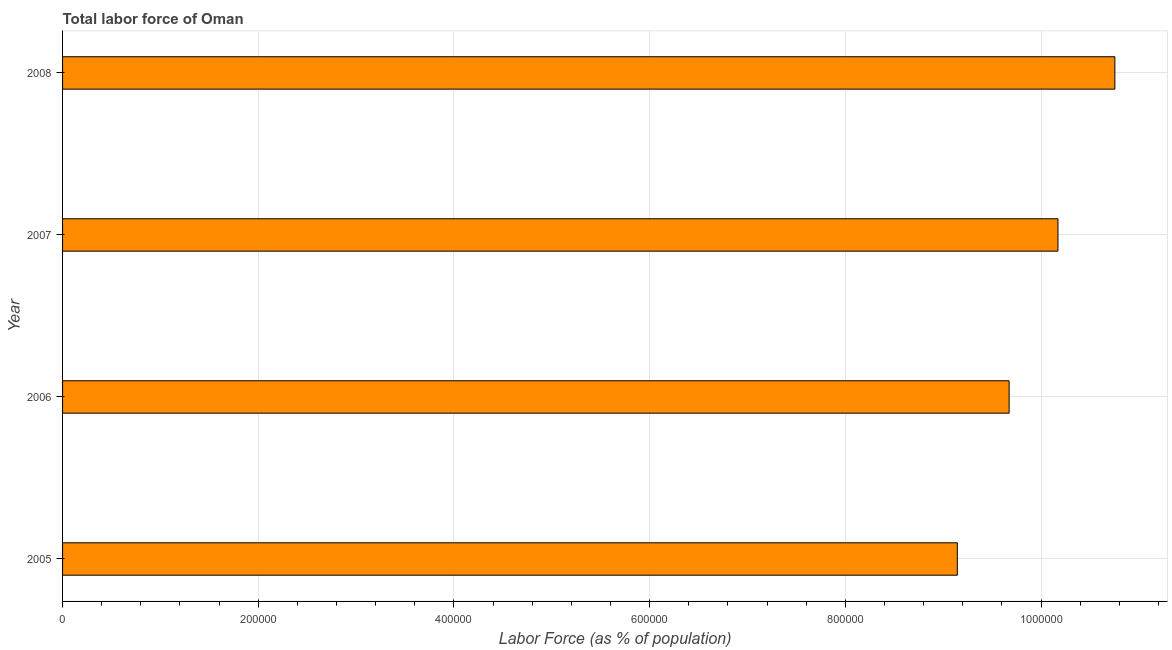Does the graph contain grids?
Keep it short and to the point. Yes. What is the title of the graph?
Your response must be concise. Total labor force of Oman. What is the label or title of the X-axis?
Keep it short and to the point. Labor Force (as % of population). What is the label or title of the Y-axis?
Give a very brief answer. Year. What is the total labor force in 2005?
Your answer should be very brief. 9.14e+05. Across all years, what is the maximum total labor force?
Provide a short and direct response. 1.08e+06. Across all years, what is the minimum total labor force?
Make the answer very short. 9.14e+05. In which year was the total labor force minimum?
Your answer should be very brief. 2005. What is the sum of the total labor force?
Keep it short and to the point. 3.97e+06. What is the difference between the total labor force in 2005 and 2006?
Offer a very short reply. -5.30e+04. What is the average total labor force per year?
Give a very brief answer. 9.94e+05. What is the median total labor force?
Offer a very short reply. 9.92e+05. What is the ratio of the total labor force in 2005 to that in 2007?
Offer a very short reply. 0.9. Is the total labor force in 2005 less than that in 2008?
Keep it short and to the point. Yes. What is the difference between the highest and the second highest total labor force?
Your answer should be compact. 5.82e+04. Is the sum of the total labor force in 2006 and 2008 greater than the maximum total labor force across all years?
Keep it short and to the point. Yes. What is the difference between the highest and the lowest total labor force?
Ensure brevity in your answer.  1.61e+05. Are all the bars in the graph horizontal?
Provide a short and direct response. Yes. How many years are there in the graph?
Make the answer very short. 4. What is the Labor Force (as % of population) of 2005?
Offer a terse response. 9.14e+05. What is the Labor Force (as % of population) of 2006?
Provide a succinct answer. 9.67e+05. What is the Labor Force (as % of population) in 2007?
Give a very brief answer. 1.02e+06. What is the Labor Force (as % of population) of 2008?
Offer a very short reply. 1.08e+06. What is the difference between the Labor Force (as % of population) in 2005 and 2006?
Your response must be concise. -5.30e+04. What is the difference between the Labor Force (as % of population) in 2005 and 2007?
Make the answer very short. -1.03e+05. What is the difference between the Labor Force (as % of population) in 2005 and 2008?
Offer a very short reply. -1.61e+05. What is the difference between the Labor Force (as % of population) in 2006 and 2007?
Your answer should be very brief. -4.99e+04. What is the difference between the Labor Force (as % of population) in 2006 and 2008?
Ensure brevity in your answer.  -1.08e+05. What is the difference between the Labor Force (as % of population) in 2007 and 2008?
Your answer should be compact. -5.82e+04. What is the ratio of the Labor Force (as % of population) in 2005 to that in 2006?
Make the answer very short. 0.94. What is the ratio of the Labor Force (as % of population) in 2005 to that in 2007?
Your answer should be very brief. 0.9. What is the ratio of the Labor Force (as % of population) in 2005 to that in 2008?
Offer a terse response. 0.85. What is the ratio of the Labor Force (as % of population) in 2006 to that in 2007?
Make the answer very short. 0.95. What is the ratio of the Labor Force (as % of population) in 2007 to that in 2008?
Your answer should be compact. 0.95. 